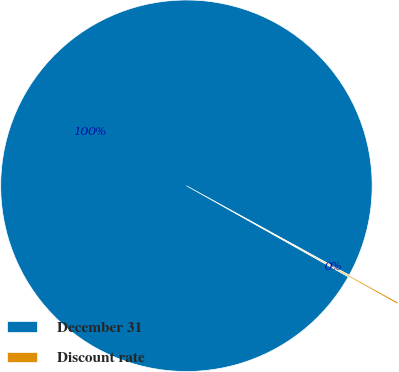<chart> <loc_0><loc_0><loc_500><loc_500><pie_chart><fcel>December 31<fcel>Discount rate<nl><fcel>99.84%<fcel>0.16%<nl></chart> 